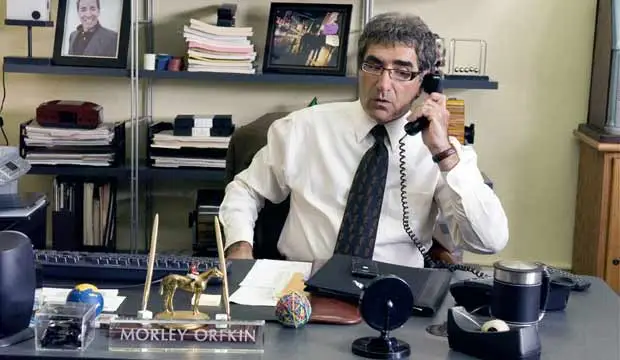Can you describe the office setting in detail? The office setting is fairly detailed and provides a peek into a professional environment. The man in the image is seated behind a desk, dressed in a white dress shirt and a striped tie. The desk itself is cluttered with various items including a gold camel statue, a black desk lamp, and a blue coffee mug. There are stacks of papers, likely indicating a busy workspace. Behind him, there are shelves filled with books and framed photos, adding a personal touch to the office. A nameplate on the desk reads 'Morley Orkin', suggesting the identity or role of the man in the photo. What can you infer about the man's character based on this photo? From the photo, it can be inferred that the man, presumably Morley Orkin, is likely a professional who takes his job seriously. His attire, which includes a white dress shirt and a striped tie, along with the organized yet busy state of his desk, suggests that he values professionalism and is perhaps in a position of some significance. The presence of a nameplate and a photo of himself in the office further indicates his importance or authority within this setting. Imagine a humorous scenario involving this character. What might it be? Imagine Morley Orkin, engulfed in a high-stakes phone call, accidentally knocking over his elaborate coffee spill-prevention device—a series of intricate dominoes and pulleys designed to save his beloved blue coffee mug from spillage. As the device hilariously malfunctions, it triggers a mini catapult that launches the gold camel statue into the air, causing a series of comical disturbances. Despite the chaos, Morley's serious demeanour never wavers, making the scenario even more amusing. 